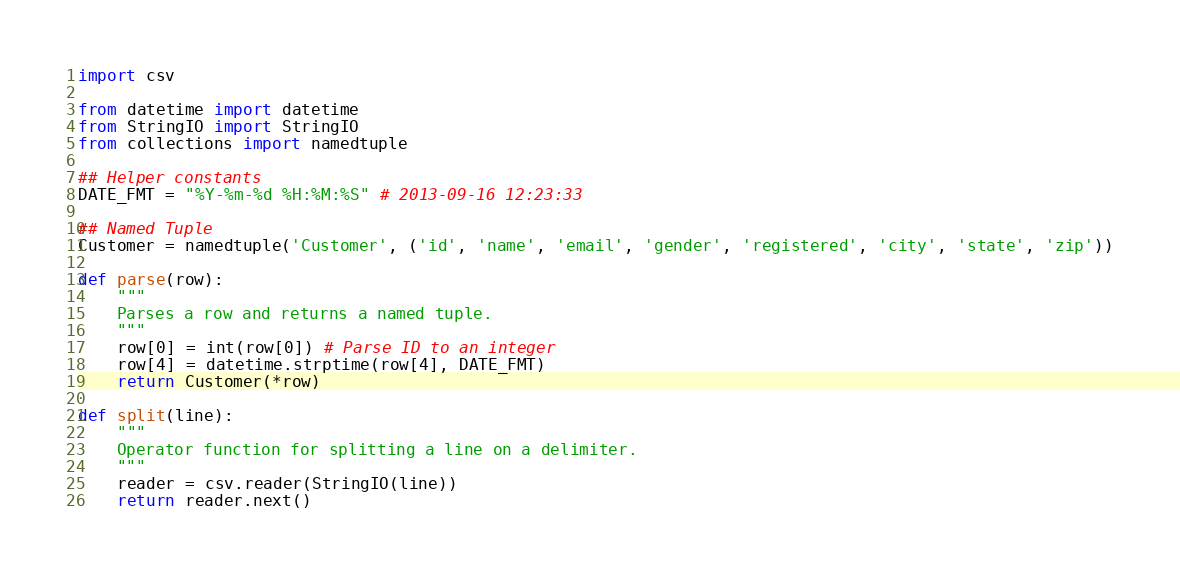Convert code to text. <code><loc_0><loc_0><loc_500><loc_500><_Python_>import csv

from datetime import datetime
from StringIO import StringIO
from collections import namedtuple

## Helper constants
DATE_FMT = "%Y-%m-%d %H:%M:%S" # 2013-09-16 12:23:33

## Named Tuple
Customer = namedtuple('Customer', ('id', 'name', 'email', 'gender', 'registered', 'city', 'state', 'zip'))

def parse(row):
    """
    Parses a row and returns a named tuple.
    """
    row[0] = int(row[0]) # Parse ID to an integer
    row[4] = datetime.strptime(row[4], DATE_FMT)
    return Customer(*row)

def split(line):
    """
    Operator function for splitting a line on a delimiter.
    """
    reader = csv.reader(StringIO(line))
    return reader.next()
</code> 